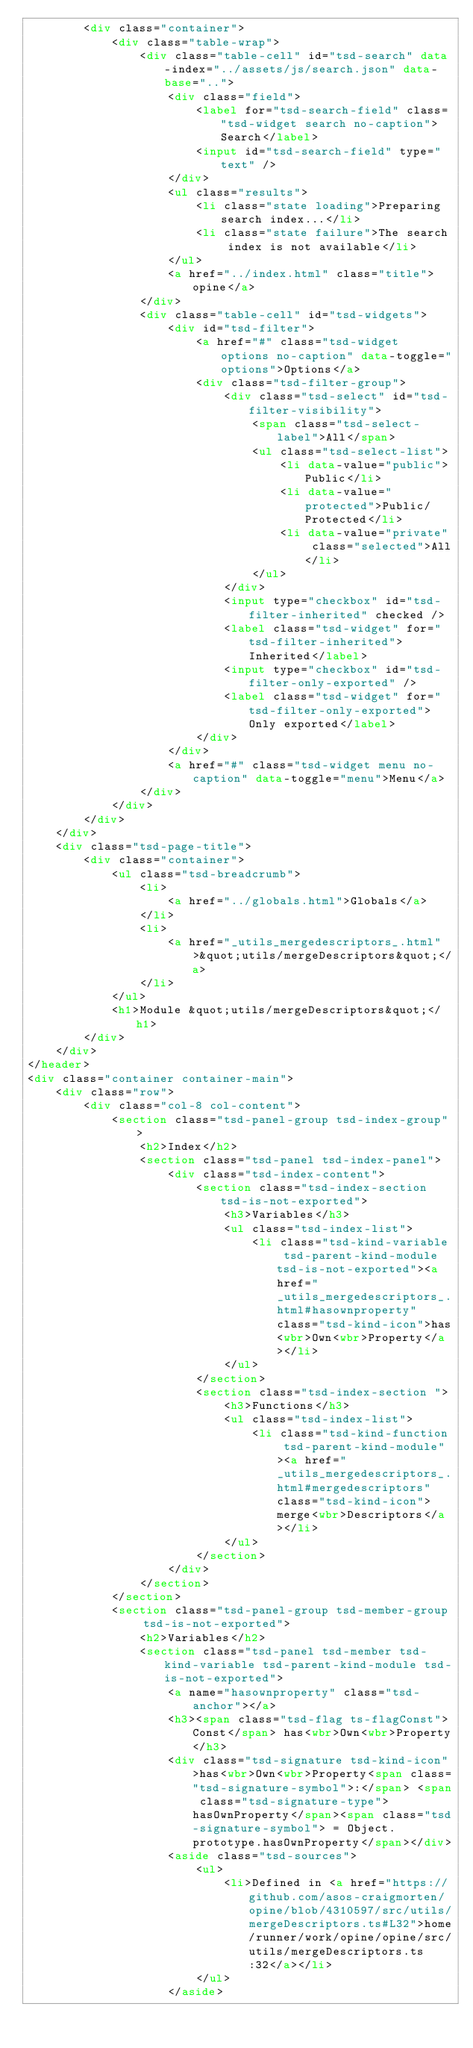<code> <loc_0><loc_0><loc_500><loc_500><_HTML_>		<div class="container">
			<div class="table-wrap">
				<div class="table-cell" id="tsd-search" data-index="../assets/js/search.json" data-base="..">
					<div class="field">
						<label for="tsd-search-field" class="tsd-widget search no-caption">Search</label>
						<input id="tsd-search-field" type="text" />
					</div>
					<ul class="results">
						<li class="state loading">Preparing search index...</li>
						<li class="state failure">The search index is not available</li>
					</ul>
					<a href="../index.html" class="title">opine</a>
				</div>
				<div class="table-cell" id="tsd-widgets">
					<div id="tsd-filter">
						<a href="#" class="tsd-widget options no-caption" data-toggle="options">Options</a>
						<div class="tsd-filter-group">
							<div class="tsd-select" id="tsd-filter-visibility">
								<span class="tsd-select-label">All</span>
								<ul class="tsd-select-list">
									<li data-value="public">Public</li>
									<li data-value="protected">Public/Protected</li>
									<li data-value="private" class="selected">All</li>
								</ul>
							</div>
							<input type="checkbox" id="tsd-filter-inherited" checked />
							<label class="tsd-widget" for="tsd-filter-inherited">Inherited</label>
							<input type="checkbox" id="tsd-filter-only-exported" />
							<label class="tsd-widget" for="tsd-filter-only-exported">Only exported</label>
						</div>
					</div>
					<a href="#" class="tsd-widget menu no-caption" data-toggle="menu">Menu</a>
				</div>
			</div>
		</div>
	</div>
	<div class="tsd-page-title">
		<div class="container">
			<ul class="tsd-breadcrumb">
				<li>
					<a href="../globals.html">Globals</a>
				</li>
				<li>
					<a href="_utils_mergedescriptors_.html">&quot;utils/mergeDescriptors&quot;</a>
				</li>
			</ul>
			<h1>Module &quot;utils/mergeDescriptors&quot;</h1>
		</div>
	</div>
</header>
<div class="container container-main">
	<div class="row">
		<div class="col-8 col-content">
			<section class="tsd-panel-group tsd-index-group">
				<h2>Index</h2>
				<section class="tsd-panel tsd-index-panel">
					<div class="tsd-index-content">
						<section class="tsd-index-section tsd-is-not-exported">
							<h3>Variables</h3>
							<ul class="tsd-index-list">
								<li class="tsd-kind-variable tsd-parent-kind-module tsd-is-not-exported"><a href="_utils_mergedescriptors_.html#hasownproperty" class="tsd-kind-icon">has<wbr>Own<wbr>Property</a></li>
							</ul>
						</section>
						<section class="tsd-index-section ">
							<h3>Functions</h3>
							<ul class="tsd-index-list">
								<li class="tsd-kind-function tsd-parent-kind-module"><a href="_utils_mergedescriptors_.html#mergedescriptors" class="tsd-kind-icon">merge<wbr>Descriptors</a></li>
							</ul>
						</section>
					</div>
				</section>
			</section>
			<section class="tsd-panel-group tsd-member-group tsd-is-not-exported">
				<h2>Variables</h2>
				<section class="tsd-panel tsd-member tsd-kind-variable tsd-parent-kind-module tsd-is-not-exported">
					<a name="hasownproperty" class="tsd-anchor"></a>
					<h3><span class="tsd-flag ts-flagConst">Const</span> has<wbr>Own<wbr>Property</h3>
					<div class="tsd-signature tsd-kind-icon">has<wbr>Own<wbr>Property<span class="tsd-signature-symbol">:</span> <span class="tsd-signature-type">hasOwnProperty</span><span class="tsd-signature-symbol"> = Object.prototype.hasOwnProperty</span></div>
					<aside class="tsd-sources">
						<ul>
							<li>Defined in <a href="https://github.com/asos-craigmorten/opine/blob/4310597/src/utils/mergeDescriptors.ts#L32">home/runner/work/opine/opine/src/utils/mergeDescriptors.ts:32</a></li>
						</ul>
					</aside></code> 